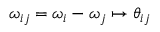Convert formula to latex. <formula><loc_0><loc_0><loc_500><loc_500>\omega _ { i j } = \omega _ { i } - \omega _ { j } \mapsto \theta _ { i j }</formula> 